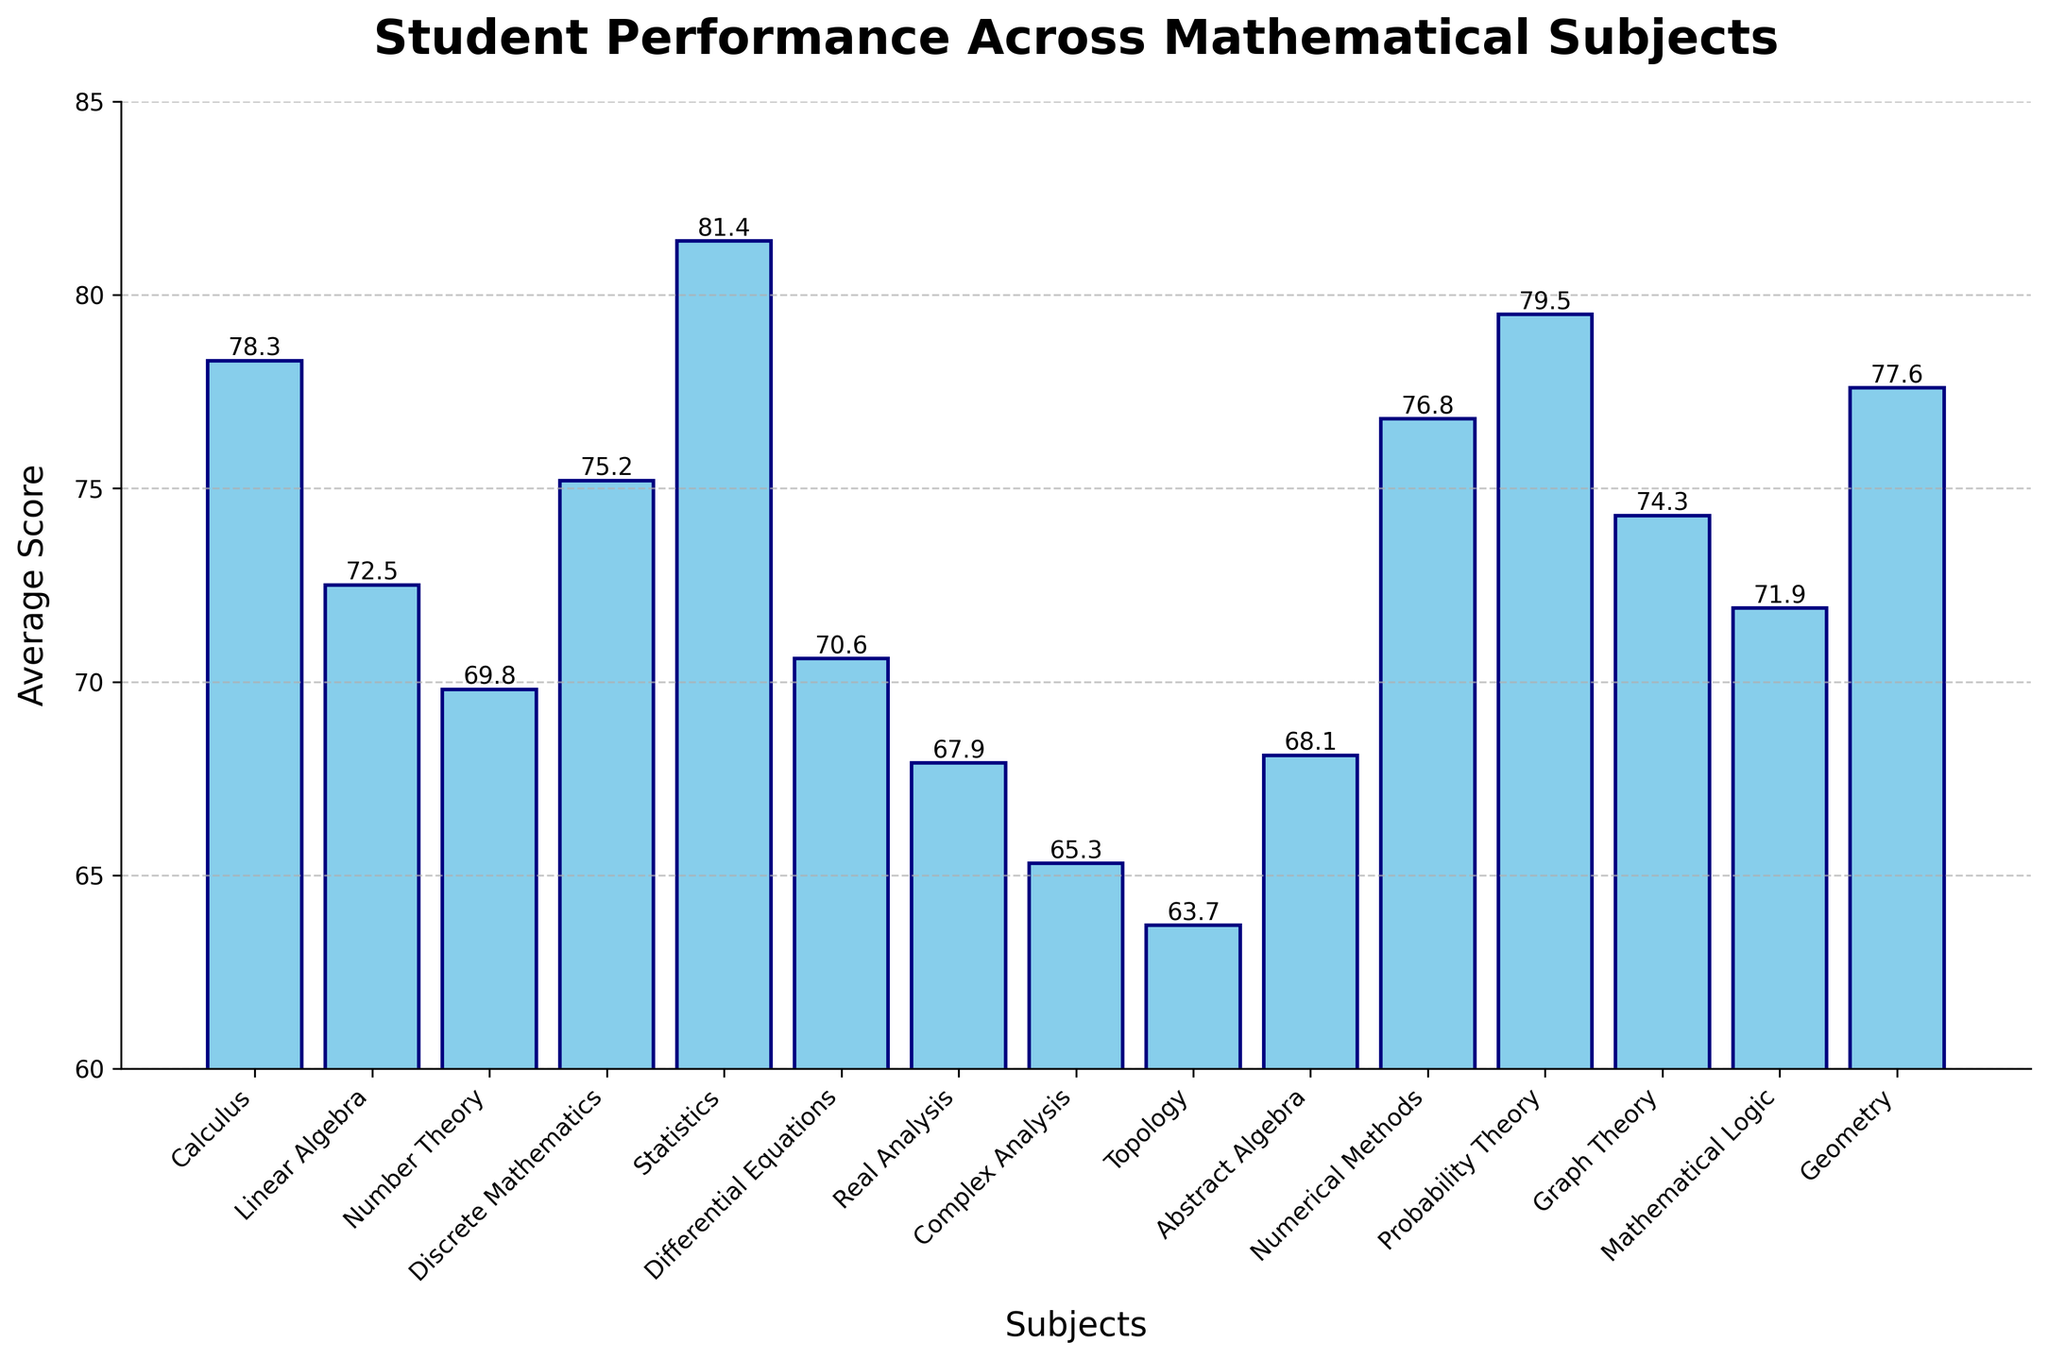Which subject has the highest average score? The subject with the highest bar represents the highest average score. By comparing the bar heights, Statistics has the highest average score.
Answer: Statistics Which subject has the lowest average score? The subject with the lowest bar represents the lowest average score. By comparing the bar heights, Topology has the lowest average score.
Answer: Topology What's the difference between the highest and lowest average scores? The highest average score is 81.4 (Statistics) and the lowest is 63.7 (Topology). The difference is calculated as 81.4 - 63.7 = 17.7.
Answer: 17.7 How many subjects have an average score greater than 75? We need to count the bars that have heights greater than 75. These are Calculus, Discrete Mathematics, Statistics, Probability Theory, Geometry, and Numerical Methods, which total 6 subjects.
Answer: 6 Which two subjects have the closest average scores? By comparing the bar heights of all subjects, it is found that Number Theory and Differential Equations have the closest average scores of 69.8 and 70.6 respectively. The difference is 0.8.
Answer: Number Theory and Differential Equations Which subjects have an average score equal to or above 80? We need to find the bars with heights equal to or above 80. Only Statistics has an average score of 81.4, which is above 80.
Answer: Statistics What is the combined average score of Discrete Mathematics and Numerical Methods? The average scores of Discrete Mathematics and Numerical Methods are 75.2 and 76.8 respectively. The combined score is 75.2 + 76.8 = 152.
Answer: 152 Which subject has an average score exactly 5 points higher than Complex Analysis? The average score of Complex Analysis is 65.3. By adding 5 to this score, we get 70.3. Among the subjects, Differential Equations has an average score of 70.6, which closely meets the criteria (closest to 70.3).
Answer: Differential Equations Arrange the first three subjects with the highest average scores in descending order. The top three subjects by average score are Statistics (81.4), Probability Theory (79.5), and Calculus (78.3). Arranging them in descending order: Statistics, Probability Theory, Calculus.
Answer: Statistics, Probability Theory, Calculus 